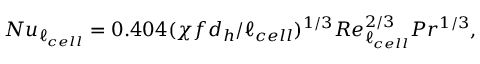<formula> <loc_0><loc_0><loc_500><loc_500>N u _ { \ell _ { c e l l } } = 0 . 4 0 4 ( \chi f d _ { h } / \ell _ { c e l l } ) ^ { 1 / 3 } R e _ { \ell _ { c e l l } } ^ { 2 / 3 } P r ^ { 1 / 3 } ,</formula> 